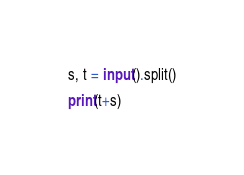Convert code to text. <code><loc_0><loc_0><loc_500><loc_500><_Python_>s, t = input().split()

print(t+s)</code> 